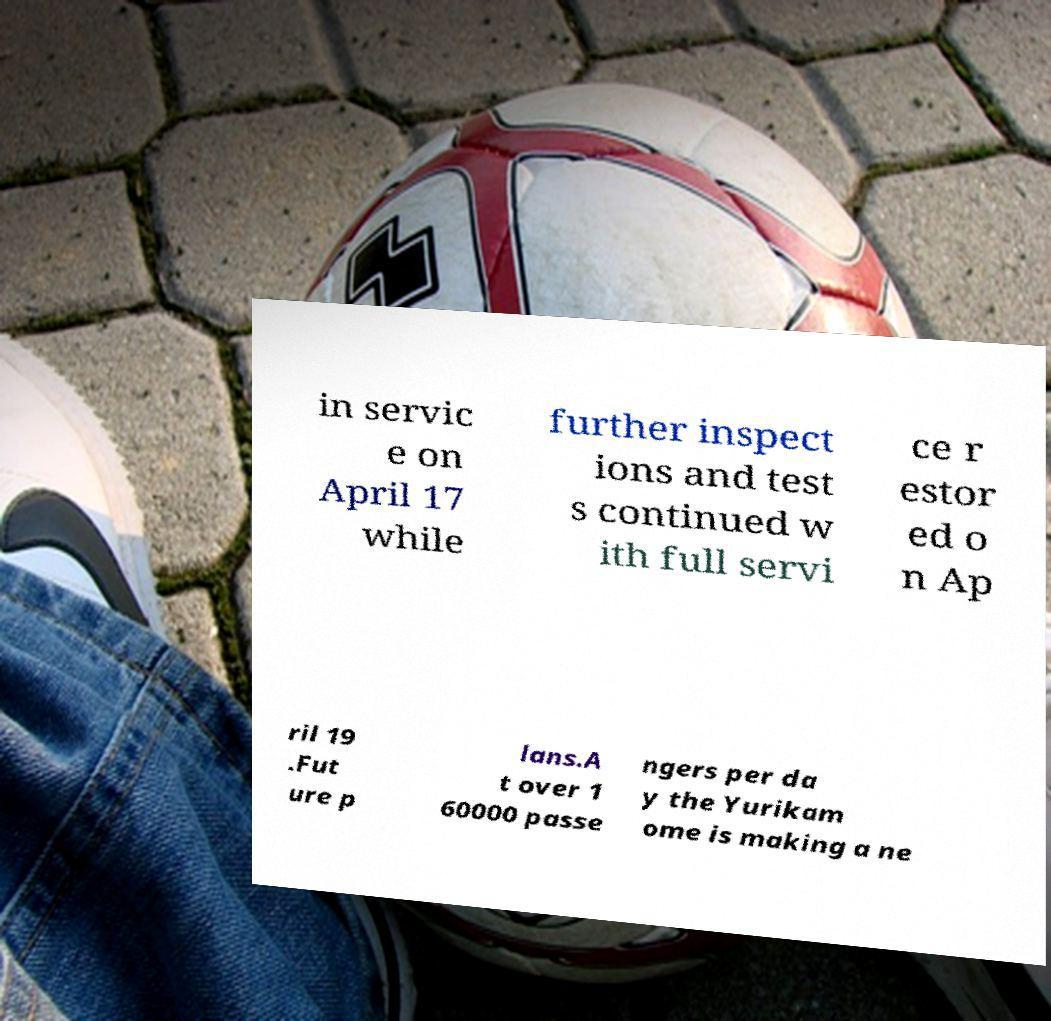What messages or text are displayed in this image? I need them in a readable, typed format. in servic e on April 17 while further inspect ions and test s continued w ith full servi ce r estor ed o n Ap ril 19 .Fut ure p lans.A t over 1 60000 passe ngers per da y the Yurikam ome is making a ne 